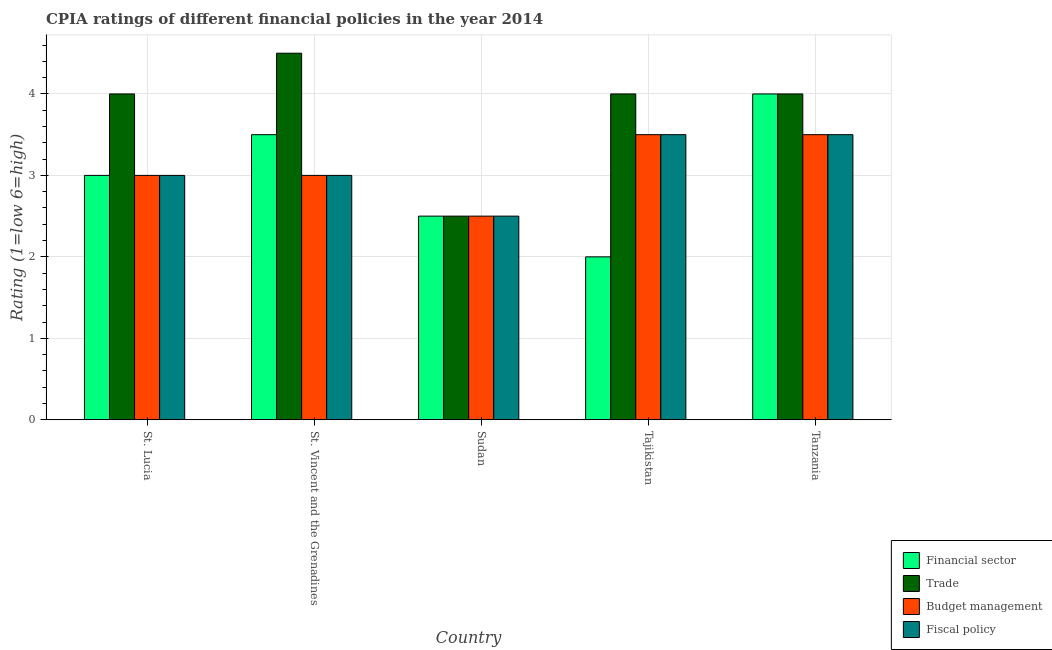Are the number of bars per tick equal to the number of legend labels?
Ensure brevity in your answer.  Yes. Are the number of bars on each tick of the X-axis equal?
Provide a short and direct response. Yes. How many bars are there on the 5th tick from the left?
Provide a short and direct response. 4. How many bars are there on the 3rd tick from the right?
Your answer should be compact. 4. What is the label of the 5th group of bars from the left?
Make the answer very short. Tanzania. Across all countries, what is the maximum cpia rating of fiscal policy?
Ensure brevity in your answer.  3.5. In which country was the cpia rating of financial sector maximum?
Ensure brevity in your answer.  Tanzania. In which country was the cpia rating of trade minimum?
Give a very brief answer. Sudan. What is the total cpia rating of budget management in the graph?
Your response must be concise. 15.5. What is the difference between the cpia rating of trade in St. Lucia and that in Tajikistan?
Your response must be concise. 0. What is the difference between the cpia rating of trade in Sudan and the cpia rating of budget management in St. Lucia?
Provide a short and direct response. -0.5. What is the average cpia rating of financial sector per country?
Your answer should be very brief. 3. In how many countries, is the cpia rating of trade greater than 4.4 ?
Provide a short and direct response. 1. What is the ratio of the cpia rating of fiscal policy in St. Lucia to that in Tanzania?
Ensure brevity in your answer.  0.86. Is the cpia rating of budget management in St. Vincent and the Grenadines less than that in Sudan?
Offer a very short reply. No. Is the difference between the cpia rating of financial sector in St. Lucia and St. Vincent and the Grenadines greater than the difference between the cpia rating of fiscal policy in St. Lucia and St. Vincent and the Grenadines?
Provide a succinct answer. No. What is the difference between the highest and the second highest cpia rating of fiscal policy?
Your answer should be compact. 0. What is the difference between the highest and the lowest cpia rating of fiscal policy?
Your answer should be very brief. 1. In how many countries, is the cpia rating of trade greater than the average cpia rating of trade taken over all countries?
Your answer should be very brief. 4. Is the sum of the cpia rating of fiscal policy in St. Vincent and the Grenadines and Tanzania greater than the maximum cpia rating of trade across all countries?
Provide a short and direct response. Yes. What does the 2nd bar from the left in Sudan represents?
Provide a succinct answer. Trade. What does the 2nd bar from the right in St. Vincent and the Grenadines represents?
Offer a terse response. Budget management. Is it the case that in every country, the sum of the cpia rating of financial sector and cpia rating of trade is greater than the cpia rating of budget management?
Offer a very short reply. Yes. How many bars are there?
Provide a succinct answer. 20. Are all the bars in the graph horizontal?
Your answer should be compact. No. Does the graph contain grids?
Offer a terse response. Yes. Where does the legend appear in the graph?
Ensure brevity in your answer.  Bottom right. How many legend labels are there?
Make the answer very short. 4. How are the legend labels stacked?
Offer a very short reply. Vertical. What is the title of the graph?
Offer a very short reply. CPIA ratings of different financial policies in the year 2014. What is the label or title of the X-axis?
Provide a short and direct response. Country. What is the label or title of the Y-axis?
Make the answer very short. Rating (1=low 6=high). What is the Rating (1=low 6=high) of Financial sector in St. Lucia?
Your response must be concise. 3. What is the Rating (1=low 6=high) in Fiscal policy in St. Lucia?
Give a very brief answer. 3. What is the Rating (1=low 6=high) of Trade in St. Vincent and the Grenadines?
Offer a very short reply. 4.5. What is the Rating (1=low 6=high) of Budget management in St. Vincent and the Grenadines?
Provide a succinct answer. 3. What is the Rating (1=low 6=high) of Fiscal policy in St. Vincent and the Grenadines?
Keep it short and to the point. 3. What is the Rating (1=low 6=high) in Financial sector in Sudan?
Make the answer very short. 2.5. What is the Rating (1=low 6=high) of Budget management in Sudan?
Give a very brief answer. 2.5. What is the Rating (1=low 6=high) in Fiscal policy in Sudan?
Offer a very short reply. 2.5. What is the Rating (1=low 6=high) of Financial sector in Tajikistan?
Keep it short and to the point. 2. What is the Rating (1=low 6=high) of Trade in Tajikistan?
Give a very brief answer. 4. What is the Rating (1=low 6=high) of Budget management in Tajikistan?
Your response must be concise. 3.5. What is the Rating (1=low 6=high) in Fiscal policy in Tajikistan?
Your answer should be compact. 3.5. What is the Rating (1=low 6=high) of Financial sector in Tanzania?
Make the answer very short. 4. Across all countries, what is the maximum Rating (1=low 6=high) of Financial sector?
Give a very brief answer. 4. Across all countries, what is the maximum Rating (1=low 6=high) of Budget management?
Provide a short and direct response. 3.5. Across all countries, what is the maximum Rating (1=low 6=high) in Fiscal policy?
Your response must be concise. 3.5. Across all countries, what is the minimum Rating (1=low 6=high) in Trade?
Provide a succinct answer. 2.5. Across all countries, what is the minimum Rating (1=low 6=high) of Budget management?
Keep it short and to the point. 2.5. What is the total Rating (1=low 6=high) of Financial sector in the graph?
Give a very brief answer. 15. What is the total Rating (1=low 6=high) in Trade in the graph?
Ensure brevity in your answer.  19. What is the difference between the Rating (1=low 6=high) in Financial sector in St. Lucia and that in St. Vincent and the Grenadines?
Offer a very short reply. -0.5. What is the difference between the Rating (1=low 6=high) in Fiscal policy in St. Lucia and that in St. Vincent and the Grenadines?
Your answer should be very brief. 0. What is the difference between the Rating (1=low 6=high) of Financial sector in St. Lucia and that in Tajikistan?
Give a very brief answer. 1. What is the difference between the Rating (1=low 6=high) in Budget management in St. Lucia and that in Tajikistan?
Keep it short and to the point. -0.5. What is the difference between the Rating (1=low 6=high) of Financial sector in St. Lucia and that in Tanzania?
Your answer should be very brief. -1. What is the difference between the Rating (1=low 6=high) in Trade in St. Lucia and that in Tanzania?
Make the answer very short. 0. What is the difference between the Rating (1=low 6=high) of Financial sector in St. Vincent and the Grenadines and that in Sudan?
Your answer should be very brief. 1. What is the difference between the Rating (1=low 6=high) of Budget management in St. Vincent and the Grenadines and that in Sudan?
Offer a terse response. 0.5. What is the difference between the Rating (1=low 6=high) in Financial sector in St. Vincent and the Grenadines and that in Tajikistan?
Make the answer very short. 1.5. What is the difference between the Rating (1=low 6=high) in Trade in St. Vincent and the Grenadines and that in Tajikistan?
Make the answer very short. 0.5. What is the difference between the Rating (1=low 6=high) in Budget management in St. Vincent and the Grenadines and that in Tajikistan?
Provide a succinct answer. -0.5. What is the difference between the Rating (1=low 6=high) in Financial sector in St. Vincent and the Grenadines and that in Tanzania?
Ensure brevity in your answer.  -0.5. What is the difference between the Rating (1=low 6=high) of Trade in St. Vincent and the Grenadines and that in Tanzania?
Give a very brief answer. 0.5. What is the difference between the Rating (1=low 6=high) in Budget management in St. Vincent and the Grenadines and that in Tanzania?
Offer a terse response. -0.5. What is the difference between the Rating (1=low 6=high) in Financial sector in Sudan and that in Tajikistan?
Provide a succinct answer. 0.5. What is the difference between the Rating (1=low 6=high) of Trade in Sudan and that in Tajikistan?
Ensure brevity in your answer.  -1.5. What is the difference between the Rating (1=low 6=high) in Budget management in Sudan and that in Tajikistan?
Provide a short and direct response. -1. What is the difference between the Rating (1=low 6=high) of Financial sector in Sudan and that in Tanzania?
Make the answer very short. -1.5. What is the difference between the Rating (1=low 6=high) in Trade in Sudan and that in Tanzania?
Your answer should be compact. -1.5. What is the difference between the Rating (1=low 6=high) of Fiscal policy in Sudan and that in Tanzania?
Make the answer very short. -1. What is the difference between the Rating (1=low 6=high) in Financial sector in Tajikistan and that in Tanzania?
Provide a succinct answer. -2. What is the difference between the Rating (1=low 6=high) of Trade in Tajikistan and that in Tanzania?
Your answer should be compact. 0. What is the difference between the Rating (1=low 6=high) of Trade in St. Lucia and the Rating (1=low 6=high) of Budget management in St. Vincent and the Grenadines?
Give a very brief answer. 1. What is the difference between the Rating (1=low 6=high) in Trade in St. Lucia and the Rating (1=low 6=high) in Fiscal policy in St. Vincent and the Grenadines?
Your response must be concise. 1. What is the difference between the Rating (1=low 6=high) of Financial sector in St. Lucia and the Rating (1=low 6=high) of Trade in Sudan?
Your answer should be very brief. 0.5. What is the difference between the Rating (1=low 6=high) of Financial sector in St. Lucia and the Rating (1=low 6=high) of Fiscal policy in Sudan?
Your answer should be compact. 0.5. What is the difference between the Rating (1=low 6=high) in Trade in St. Lucia and the Rating (1=low 6=high) in Budget management in Sudan?
Your answer should be compact. 1.5. What is the difference between the Rating (1=low 6=high) of Budget management in St. Lucia and the Rating (1=low 6=high) of Fiscal policy in Sudan?
Your answer should be compact. 0.5. What is the difference between the Rating (1=low 6=high) of Financial sector in St. Lucia and the Rating (1=low 6=high) of Fiscal policy in Tajikistan?
Your answer should be very brief. -0.5. What is the difference between the Rating (1=low 6=high) in Financial sector in St. Lucia and the Rating (1=low 6=high) in Trade in Tanzania?
Keep it short and to the point. -1. What is the difference between the Rating (1=low 6=high) in Financial sector in St. Lucia and the Rating (1=low 6=high) in Budget management in Tanzania?
Offer a terse response. -0.5. What is the difference between the Rating (1=low 6=high) of Financial sector in St. Lucia and the Rating (1=low 6=high) of Fiscal policy in Tanzania?
Your response must be concise. -0.5. What is the difference between the Rating (1=low 6=high) of Trade in St. Lucia and the Rating (1=low 6=high) of Fiscal policy in Tanzania?
Keep it short and to the point. 0.5. What is the difference between the Rating (1=low 6=high) in Budget management in St. Lucia and the Rating (1=low 6=high) in Fiscal policy in Tanzania?
Offer a very short reply. -0.5. What is the difference between the Rating (1=low 6=high) of Trade in St. Vincent and the Grenadines and the Rating (1=low 6=high) of Budget management in Sudan?
Ensure brevity in your answer.  2. What is the difference between the Rating (1=low 6=high) in Trade in St. Vincent and the Grenadines and the Rating (1=low 6=high) in Fiscal policy in Sudan?
Make the answer very short. 2. What is the difference between the Rating (1=low 6=high) of Financial sector in St. Vincent and the Grenadines and the Rating (1=low 6=high) of Trade in Tajikistan?
Your response must be concise. -0.5. What is the difference between the Rating (1=low 6=high) of Financial sector in St. Vincent and the Grenadines and the Rating (1=low 6=high) of Fiscal policy in Tajikistan?
Provide a short and direct response. 0. What is the difference between the Rating (1=low 6=high) of Trade in St. Vincent and the Grenadines and the Rating (1=low 6=high) of Budget management in Tajikistan?
Ensure brevity in your answer.  1. What is the difference between the Rating (1=low 6=high) in Trade in St. Vincent and the Grenadines and the Rating (1=low 6=high) in Fiscal policy in Tajikistan?
Your response must be concise. 1. What is the difference between the Rating (1=low 6=high) in Budget management in St. Vincent and the Grenadines and the Rating (1=low 6=high) in Fiscal policy in Tajikistan?
Offer a very short reply. -0.5. What is the difference between the Rating (1=low 6=high) of Financial sector in St. Vincent and the Grenadines and the Rating (1=low 6=high) of Trade in Tanzania?
Provide a short and direct response. -0.5. What is the difference between the Rating (1=low 6=high) of Trade in St. Vincent and the Grenadines and the Rating (1=low 6=high) of Budget management in Tanzania?
Offer a terse response. 1. What is the difference between the Rating (1=low 6=high) of Budget management in St. Vincent and the Grenadines and the Rating (1=low 6=high) of Fiscal policy in Tanzania?
Ensure brevity in your answer.  -0.5. What is the difference between the Rating (1=low 6=high) of Financial sector in Sudan and the Rating (1=low 6=high) of Trade in Tajikistan?
Make the answer very short. -1.5. What is the difference between the Rating (1=low 6=high) of Financial sector in Sudan and the Rating (1=low 6=high) of Budget management in Tajikistan?
Keep it short and to the point. -1. What is the difference between the Rating (1=low 6=high) in Financial sector in Sudan and the Rating (1=low 6=high) in Fiscal policy in Tajikistan?
Offer a very short reply. -1. What is the difference between the Rating (1=low 6=high) in Trade in Sudan and the Rating (1=low 6=high) in Budget management in Tajikistan?
Your answer should be compact. -1. What is the difference between the Rating (1=low 6=high) of Financial sector in Sudan and the Rating (1=low 6=high) of Budget management in Tanzania?
Provide a short and direct response. -1. What is the difference between the Rating (1=low 6=high) in Trade in Tajikistan and the Rating (1=low 6=high) in Budget management in Tanzania?
Your answer should be very brief. 0.5. What is the difference between the Rating (1=low 6=high) of Budget management in Tajikistan and the Rating (1=low 6=high) of Fiscal policy in Tanzania?
Your answer should be very brief. 0. What is the average Rating (1=low 6=high) of Financial sector per country?
Make the answer very short. 3. What is the average Rating (1=low 6=high) of Fiscal policy per country?
Provide a short and direct response. 3.1. What is the difference between the Rating (1=low 6=high) in Financial sector and Rating (1=low 6=high) in Trade in St. Lucia?
Make the answer very short. -1. What is the difference between the Rating (1=low 6=high) of Financial sector and Rating (1=low 6=high) of Budget management in St. Lucia?
Give a very brief answer. 0. What is the difference between the Rating (1=low 6=high) of Financial sector and Rating (1=low 6=high) of Budget management in St. Vincent and the Grenadines?
Provide a succinct answer. 0.5. What is the difference between the Rating (1=low 6=high) in Financial sector and Rating (1=low 6=high) in Fiscal policy in St. Vincent and the Grenadines?
Keep it short and to the point. 0.5. What is the difference between the Rating (1=low 6=high) of Trade and Rating (1=low 6=high) of Budget management in St. Vincent and the Grenadines?
Provide a short and direct response. 1.5. What is the difference between the Rating (1=low 6=high) of Trade and Rating (1=low 6=high) of Fiscal policy in St. Vincent and the Grenadines?
Offer a very short reply. 1.5. What is the difference between the Rating (1=low 6=high) of Financial sector and Rating (1=low 6=high) of Trade in Sudan?
Offer a terse response. 0. What is the difference between the Rating (1=low 6=high) of Trade and Rating (1=low 6=high) of Fiscal policy in Sudan?
Make the answer very short. 0. What is the difference between the Rating (1=low 6=high) of Trade and Rating (1=low 6=high) of Budget management in Tajikistan?
Ensure brevity in your answer.  0.5. What is the difference between the Rating (1=low 6=high) in Financial sector and Rating (1=low 6=high) in Fiscal policy in Tanzania?
Give a very brief answer. 0.5. What is the difference between the Rating (1=low 6=high) in Budget management and Rating (1=low 6=high) in Fiscal policy in Tanzania?
Provide a succinct answer. 0. What is the ratio of the Rating (1=low 6=high) in Trade in St. Lucia to that in St. Vincent and the Grenadines?
Keep it short and to the point. 0.89. What is the ratio of the Rating (1=low 6=high) in Budget management in St. Lucia to that in St. Vincent and the Grenadines?
Your answer should be compact. 1. What is the ratio of the Rating (1=low 6=high) in Budget management in St. Lucia to that in Sudan?
Your response must be concise. 1.2. What is the ratio of the Rating (1=low 6=high) of Financial sector in St. Lucia to that in Tajikistan?
Keep it short and to the point. 1.5. What is the ratio of the Rating (1=low 6=high) in Trade in St. Lucia to that in Tajikistan?
Provide a succinct answer. 1. What is the ratio of the Rating (1=low 6=high) of Fiscal policy in St. Lucia to that in Tajikistan?
Keep it short and to the point. 0.86. What is the ratio of the Rating (1=low 6=high) in Financial sector in St. Lucia to that in Tanzania?
Provide a succinct answer. 0.75. What is the ratio of the Rating (1=low 6=high) of Trade in St. Lucia to that in Tanzania?
Make the answer very short. 1. What is the ratio of the Rating (1=low 6=high) of Budget management in St. Lucia to that in Tanzania?
Keep it short and to the point. 0.86. What is the ratio of the Rating (1=low 6=high) of Financial sector in St. Vincent and the Grenadines to that in Sudan?
Offer a very short reply. 1.4. What is the ratio of the Rating (1=low 6=high) of Budget management in St. Vincent and the Grenadines to that in Sudan?
Provide a succinct answer. 1.2. What is the ratio of the Rating (1=low 6=high) in Fiscal policy in St. Vincent and the Grenadines to that in Sudan?
Provide a succinct answer. 1.2. What is the ratio of the Rating (1=low 6=high) of Budget management in St. Vincent and the Grenadines to that in Tanzania?
Your answer should be very brief. 0.86. What is the ratio of the Rating (1=low 6=high) of Fiscal policy in St. Vincent and the Grenadines to that in Tanzania?
Ensure brevity in your answer.  0.86. What is the ratio of the Rating (1=low 6=high) of Fiscal policy in Sudan to that in Tajikistan?
Offer a terse response. 0.71. What is the ratio of the Rating (1=low 6=high) in Trade in Sudan to that in Tanzania?
Your answer should be compact. 0.62. What is the ratio of the Rating (1=low 6=high) of Fiscal policy in Sudan to that in Tanzania?
Your answer should be compact. 0.71. What is the ratio of the Rating (1=low 6=high) of Financial sector in Tajikistan to that in Tanzania?
Provide a short and direct response. 0.5. What is the ratio of the Rating (1=low 6=high) of Trade in Tajikistan to that in Tanzania?
Keep it short and to the point. 1. What is the difference between the highest and the second highest Rating (1=low 6=high) in Trade?
Make the answer very short. 0.5. What is the difference between the highest and the second highest Rating (1=low 6=high) of Budget management?
Offer a very short reply. 0. What is the difference between the highest and the lowest Rating (1=low 6=high) in Trade?
Make the answer very short. 2. What is the difference between the highest and the lowest Rating (1=low 6=high) in Budget management?
Provide a short and direct response. 1. 